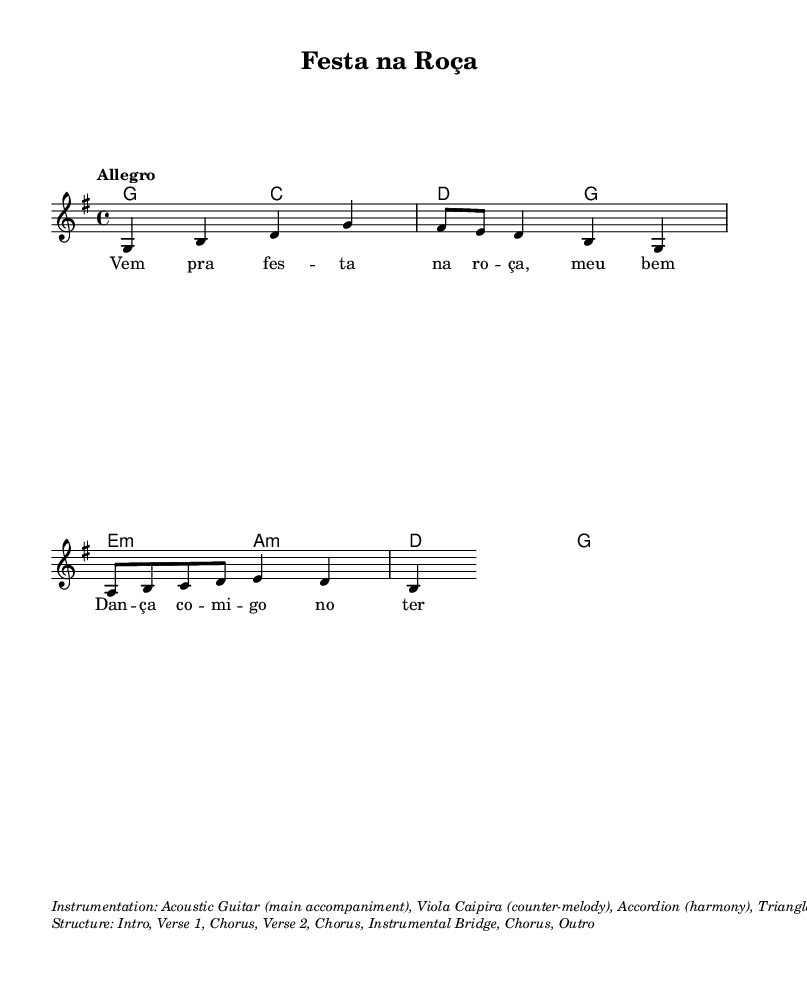What is the key signature of this music? The key signature is G major, which has one sharp (F#). You can determine this from the global context of the score, where the key is explicitly stated.
Answer: G major What is the time signature of this music? The time signature is 4/4. This is noted in the global section of the music sheet, indicating that there are four beats per measure.
Answer: 4/4 What is the tempo marking for the piece? The tempo marking is "Allegro." This term is included in the global section and indicates a fast tempo for the piece.
Answer: Allegro How many verses are included in the structure of the song? The structure mentions two verses along with a chorus and other sections, which can be inferred from the breakdown provided in the markup regarding the song's structure.
Answer: Two What instrument provides the main accompaniment? The main accompaniment is given by the Acoustic Guitar, as specified in the instrumentation section of the markup.
Answer: Acoustic Guitar What is the harmonic progression for the first chord in the piece? The harmonies begin with a G chord. This can be seen in the chord mode at the beginning of the score, where the first chord is indeed G.
Answer: G What rhythmic instrument is used for the accent in this piece? The rhythmic accent is provided by the Triangle, which is mentioned in the instrumentation notes within the markup.
Answer: Triangle 